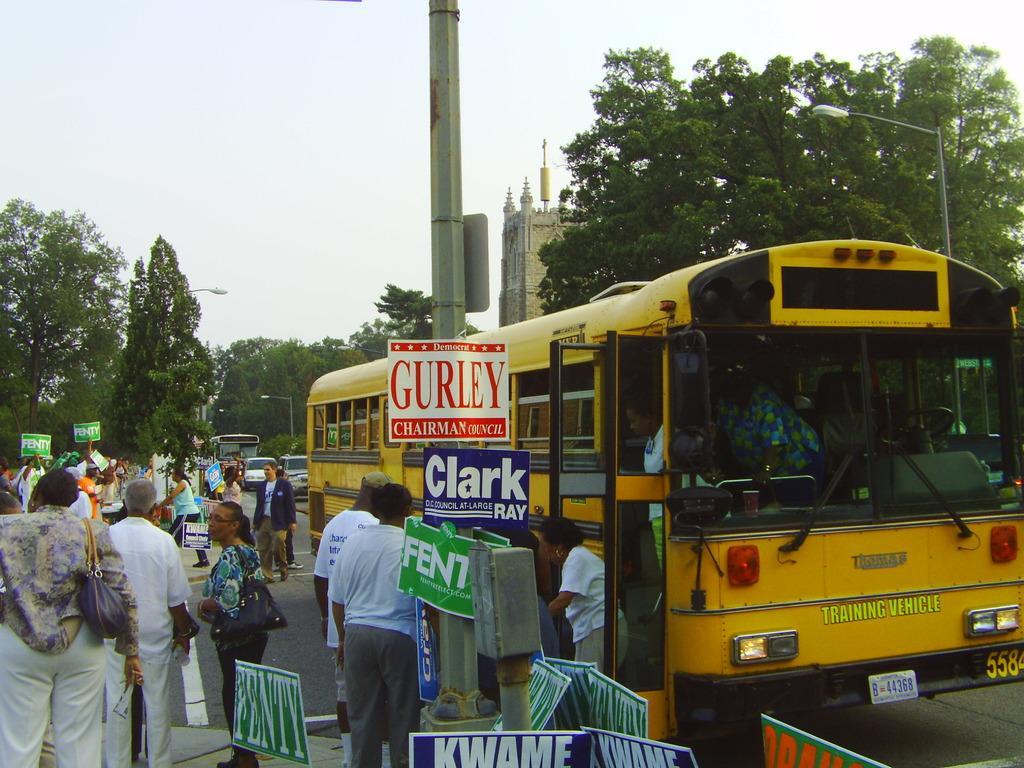How would you summarize this image in a sentence or two? In this picture we can see a group of people standing and some people holding the boards. On the right side of the people there are some vehicles on the road. Behind the people, there is a pole with the boards. In front of the people there are trees, a building, poles with lights and the sky. 